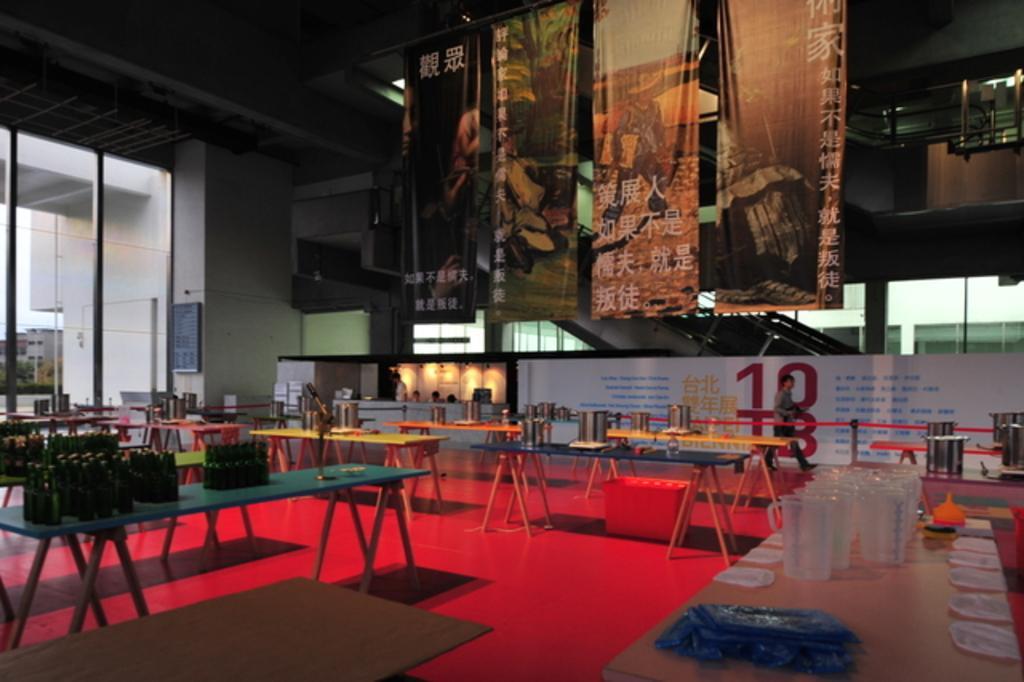Describe this image in one or two sentences. It looks like inside view of the hall, there are some table with objects on it, the objects are bottles, glasses and other, we can see some people, posters with some images and text, also we can see a glass door, through it we can see some trees and buildings. 